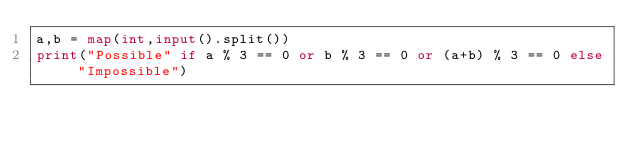Convert code to text. <code><loc_0><loc_0><loc_500><loc_500><_Python_>a,b = map(int,input().split())
print("Possible" if a % 3 == 0 or b % 3 == 0 or (a+b) % 3 == 0 else "Impossible")</code> 